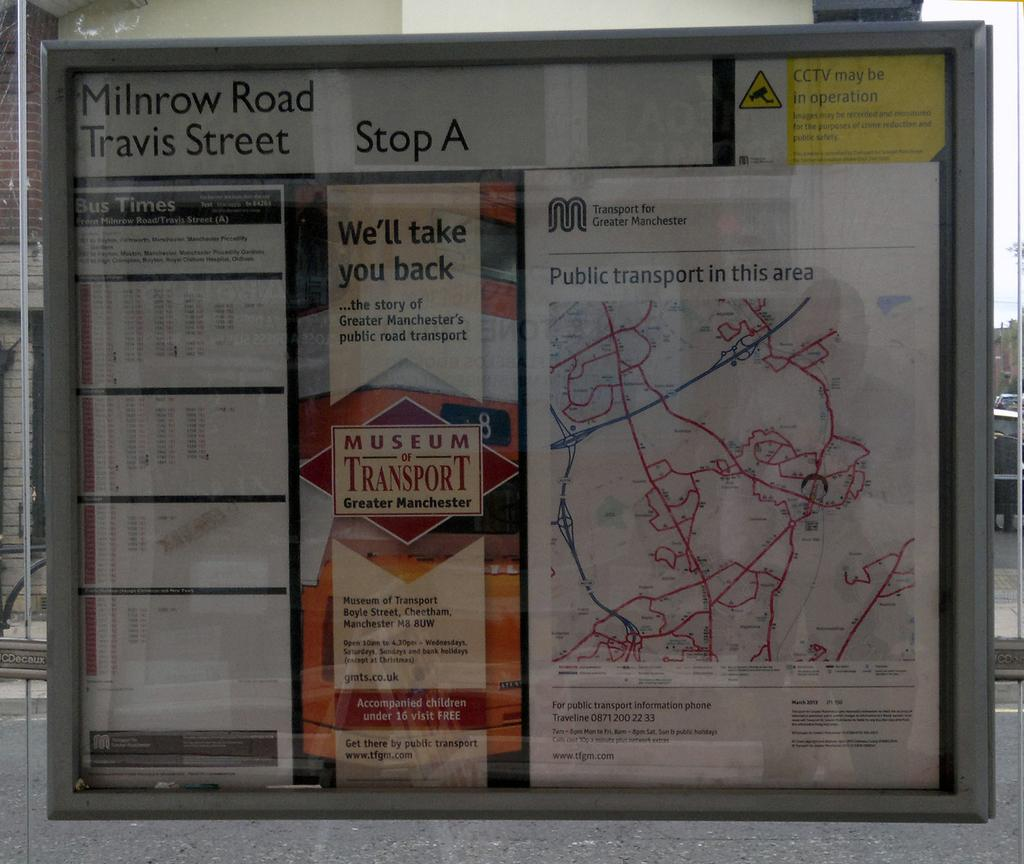<image>
Describe the image concisely. A sign for the Milnrow Road Travis Street at Stop A with a map. 